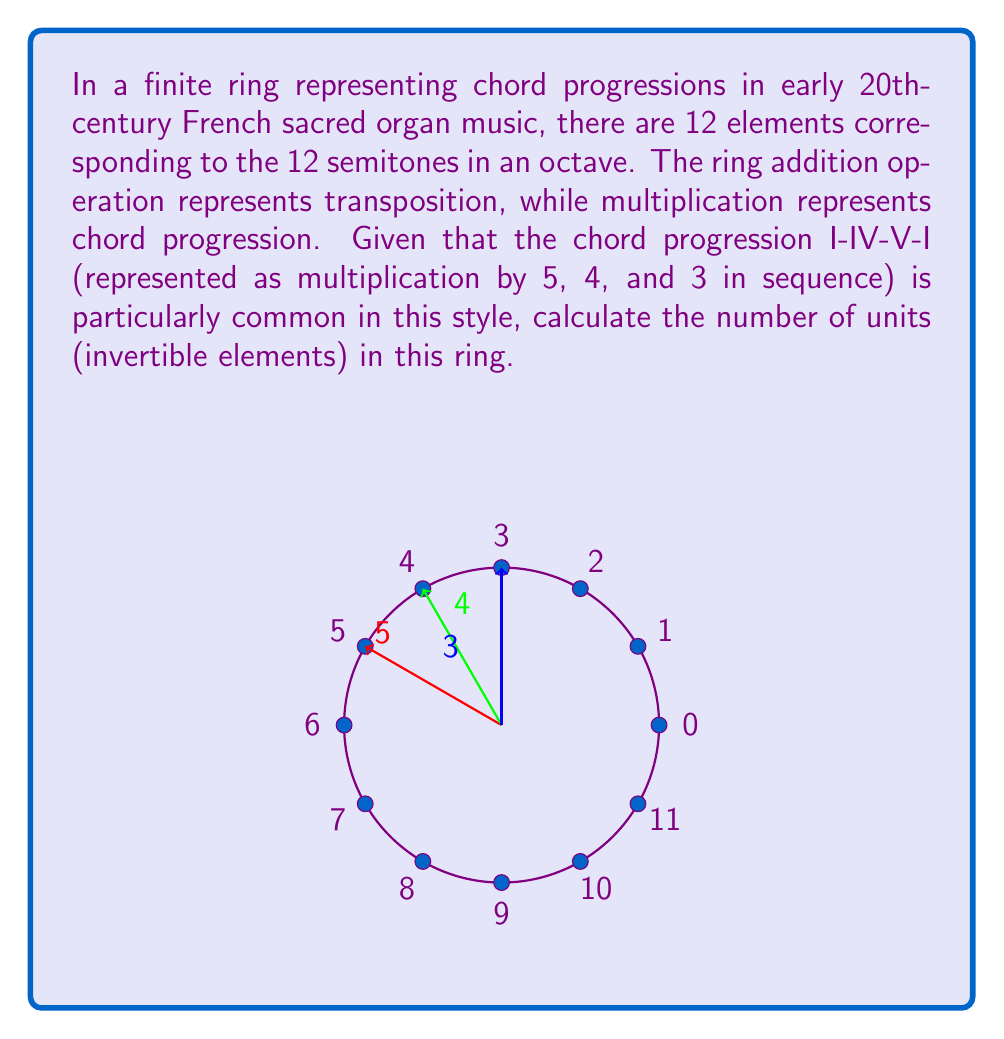Give your solution to this math problem. To find the number of units in this finite ring, we need to determine how many elements have multiplicative inverses. In a ring with 12 elements (representing the 12 semitones), an element is a unit if and only if it is coprime to 12.

Step 1: List the elements of the ring.
The elements are $\{0, 1, 2, 3, 4, 5, 6, 7, 8, 9, 10, 11\}$.

Step 2: Determine which elements are coprime to 12.
An element $a$ is coprime to 12 if $\gcd(a,12) = 1$.

$\gcd(1,12) = 1$
$\gcd(5,12) = 1$
$\gcd(7,12) = 1$
$\gcd(11,12) = 1$

Step 3: Count the number of coprime elements.
There are 4 elements coprime to 12: 1, 5, 7, and 11.

Step 4: Interpret the result in terms of chord progressions.
Each of these units represents a unique chord progression that, when repeated, will eventually return to the starting chord. For example:

- 1 represents staying on the same chord (I-I-I-I)
- 5 represents the progression I-V-II-VI-III-VII-IV-I
- 7 represents the progression I-VII-V-III-I
- 11 represents the retrograde of the progression represented by 1

These progressions are particularly important in early 20th-century French sacred organ music, as they provide a sense of tonal center and harmonic movement characteristic of the style.
Answer: 4 units 